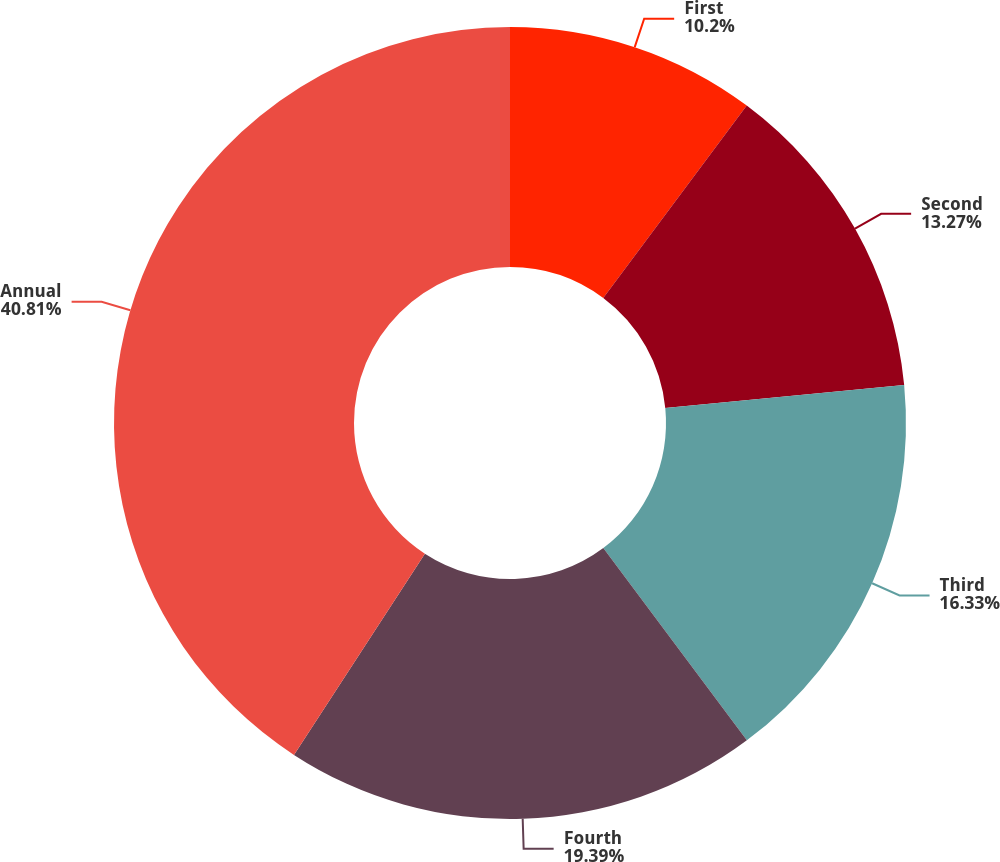Convert chart to OTSL. <chart><loc_0><loc_0><loc_500><loc_500><pie_chart><fcel>First<fcel>Second<fcel>Third<fcel>Fourth<fcel>Annual<nl><fcel>10.2%<fcel>13.27%<fcel>16.33%<fcel>19.39%<fcel>40.82%<nl></chart> 